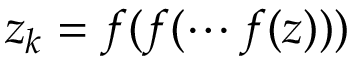Convert formula to latex. <formula><loc_0><loc_0><loc_500><loc_500>z _ { k } = f ( f ( \cdots f ( z ) ) )</formula> 